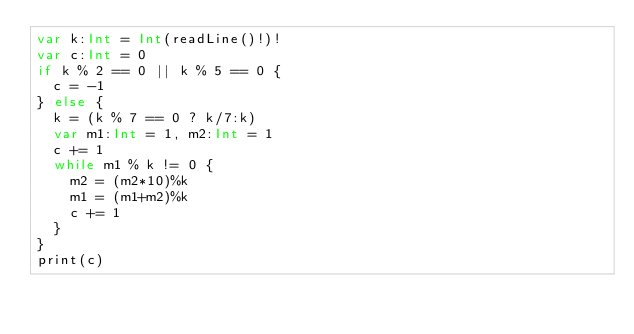<code> <loc_0><loc_0><loc_500><loc_500><_Swift_>var k:Int = Int(readLine()!)!
var c:Int = 0
if k % 2 == 0 || k % 5 == 0 {
  c = -1
} else {
  k = (k % 7 == 0 ? k/7:k)
  var m1:Int = 1, m2:Int = 1
  c += 1
  while m1 % k != 0 {
    m2 = (m2*10)%k
    m1 = (m1+m2)%k
    c += 1
  }
}
print(c)</code> 